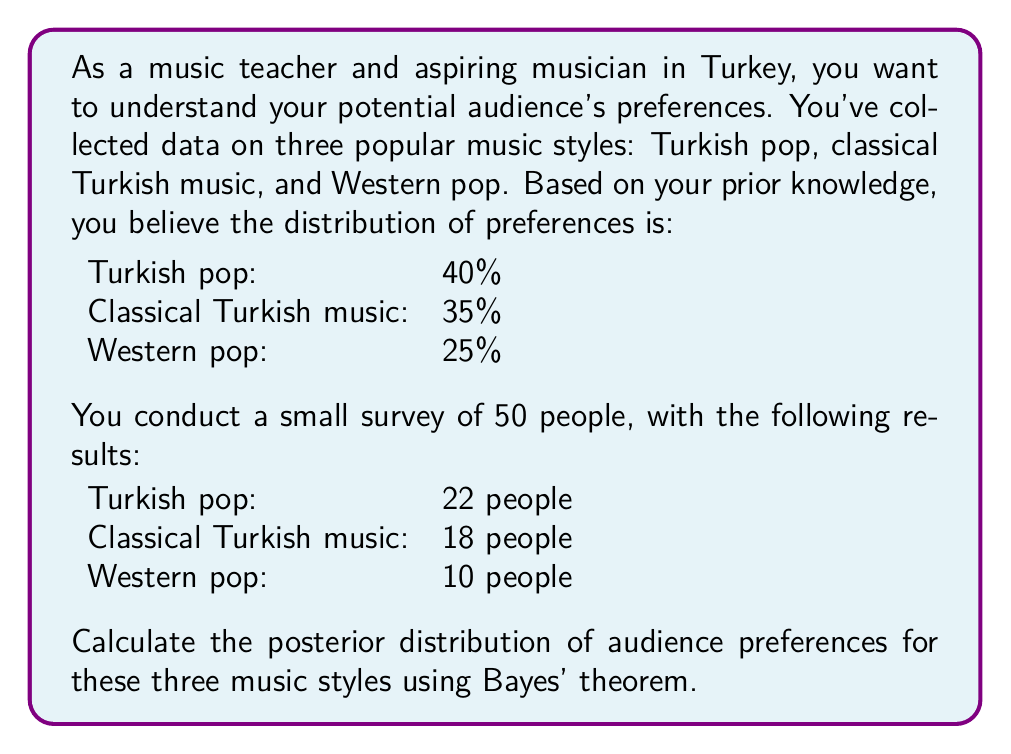Solve this math problem. To solve this problem, we'll use Bayes' theorem to update our prior beliefs based on the new evidence from the survey. We'll calculate the posterior probability for each music style.

1. Define our variables:
   A = Turkish pop
   B = Classical Turkish music
   C = Western pop

2. Prior probabilities:
   P(A) = 0.40
   P(B) = 0.35
   P(C) = 0.25

3. Likelihood (based on survey results):
   P(Data|A) = $\frac{22}{50} = 0.44$
   P(Data|B) = $\frac{18}{50} = 0.36$
   P(Data|C) = $\frac{10}{50} = 0.20$

4. Calculate the marginal likelihood:
   P(Data) = P(Data|A) * P(A) + P(Data|B) * P(B) + P(Data|C) * P(C)
   P(Data) = 0.44 * 0.40 + 0.36 * 0.35 + 0.20 * 0.25 = 0.356

5. Apply Bayes' theorem for each music style:

   For Turkish pop (A):
   $$P(A|Data) = \frac{P(Data|A) * P(A)}{P(Data)} = \frac{0.44 * 0.40}{0.356} = 0.4944$$

   For Classical Turkish music (B):
   $$P(B|Data) = \frac{P(Data|B) * P(B)}{P(Data)} = \frac{0.36 * 0.35}{0.356} = 0.3539$$

   For Western pop (C):
   $$P(C|Data) = \frac{P(Data|C) * P(C)}{P(Data)} = \frac{0.20 * 0.25}{0.356} = 0.1517$$

6. Convert to percentages:
   Turkish pop: 49.44%
   Classical Turkish music: 35.39%
   Western pop: 15.17%
Answer: The posterior distribution of audience preferences:
Turkish pop: 49.44%
Classical Turkish music: 35.39%
Western pop: 15.17% 